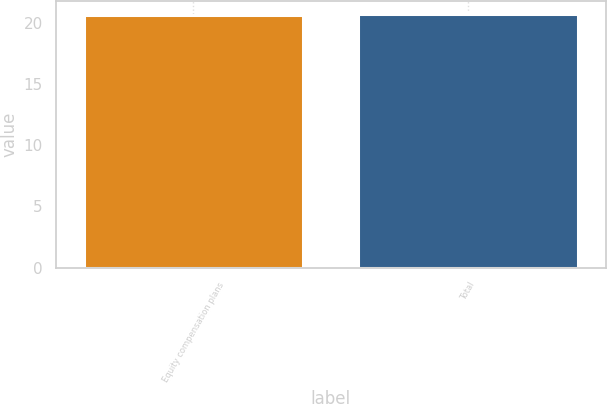<chart> <loc_0><loc_0><loc_500><loc_500><bar_chart><fcel>Equity compensation plans<fcel>Total<nl><fcel>20.6<fcel>20.7<nl></chart> 